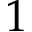<formula> <loc_0><loc_0><loc_500><loc_500>1</formula> 